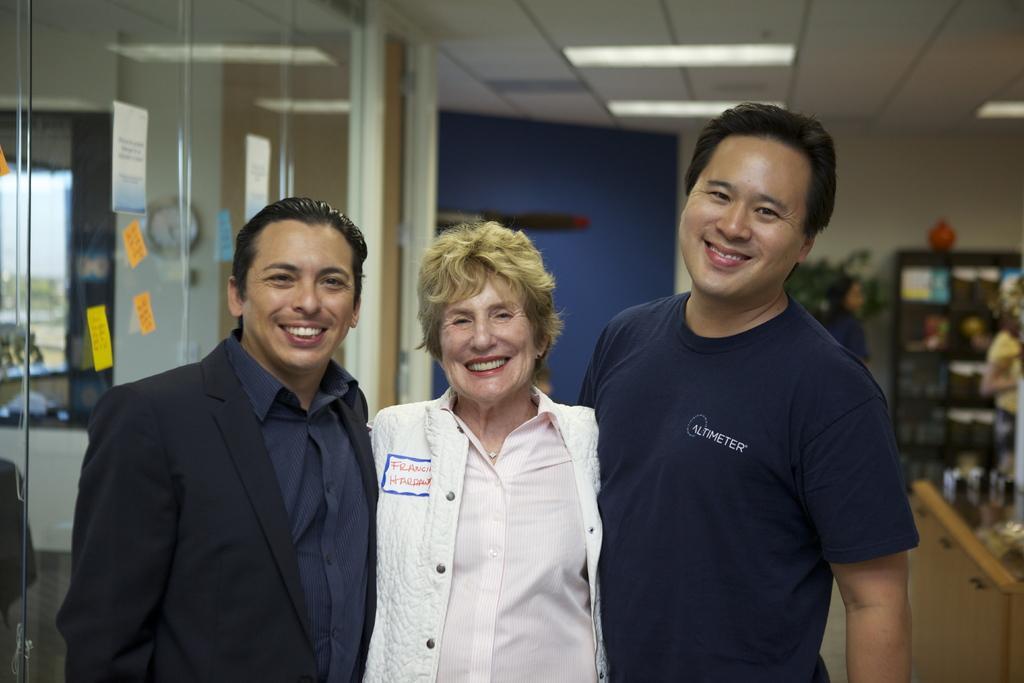Can you describe this image briefly? This picture is clicked inside the room. In the foreground we can see the three persons smiling and standing on the ground. On the right corner we can see a cabinet containing many number of items and there are some items placed on the ground. At the top there is a roof and we can see the ceiling lights. On the left corner we can see the papers attached to the glass and we can see a clock hanging on the wall and we can see a window and through the window we can see the outside view. In the background we can see the wall and a person and some other objects. 